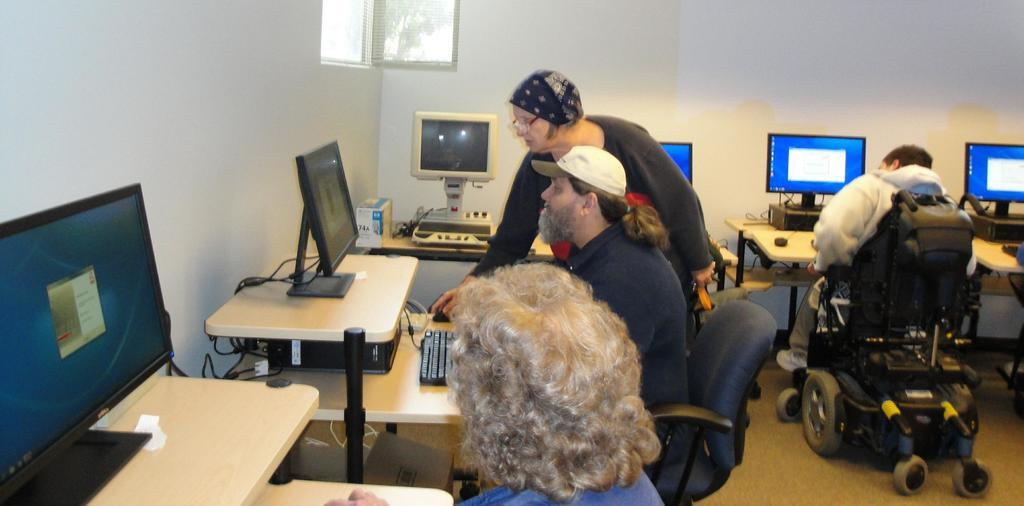What type of setting is shown in the image? The image depicts a lab. What are the people in the image doing? There are three people sitting in front of systems on a table. Is there anyone standing in the image? Yes, one person is standing in the image. What level of the building is the chess game taking place on in the image? There is no chess game present in the image, and therefore no level can be determined. 